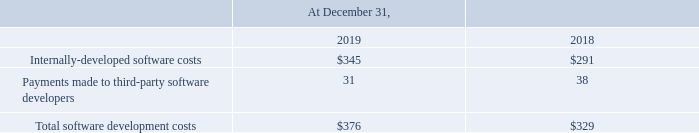5. Software Development and Intellectual Property Licenses
The following table summarizes the components of our capitalized software development costs (amounts in millions):
As of both December 31, 2019 and December 31, 2018, capitalized intellectual property licenses were not material.
What were the Internally-developed software costs in 2019?
Answer scale should be: million. 345. What was the amounts of Payments made to third-party software developers in 2019?
Answer scale should be: million. 31. What was the total software development costs in 2018?
Answer scale should be: million. 329. What was the change in Internally-developed software costs between 2018 and 2019?
Answer scale should be: million. $345-$291
Answer: 54. What was the change in payments made to third-party software developers between 2018 and 2019?
Answer scale should be: million. 31-38
Answer: -7. What was the percentage change in total software development costs between 2018 and 2019?
Answer scale should be: percent. ($376-$329)/$329
Answer: 14.29. 